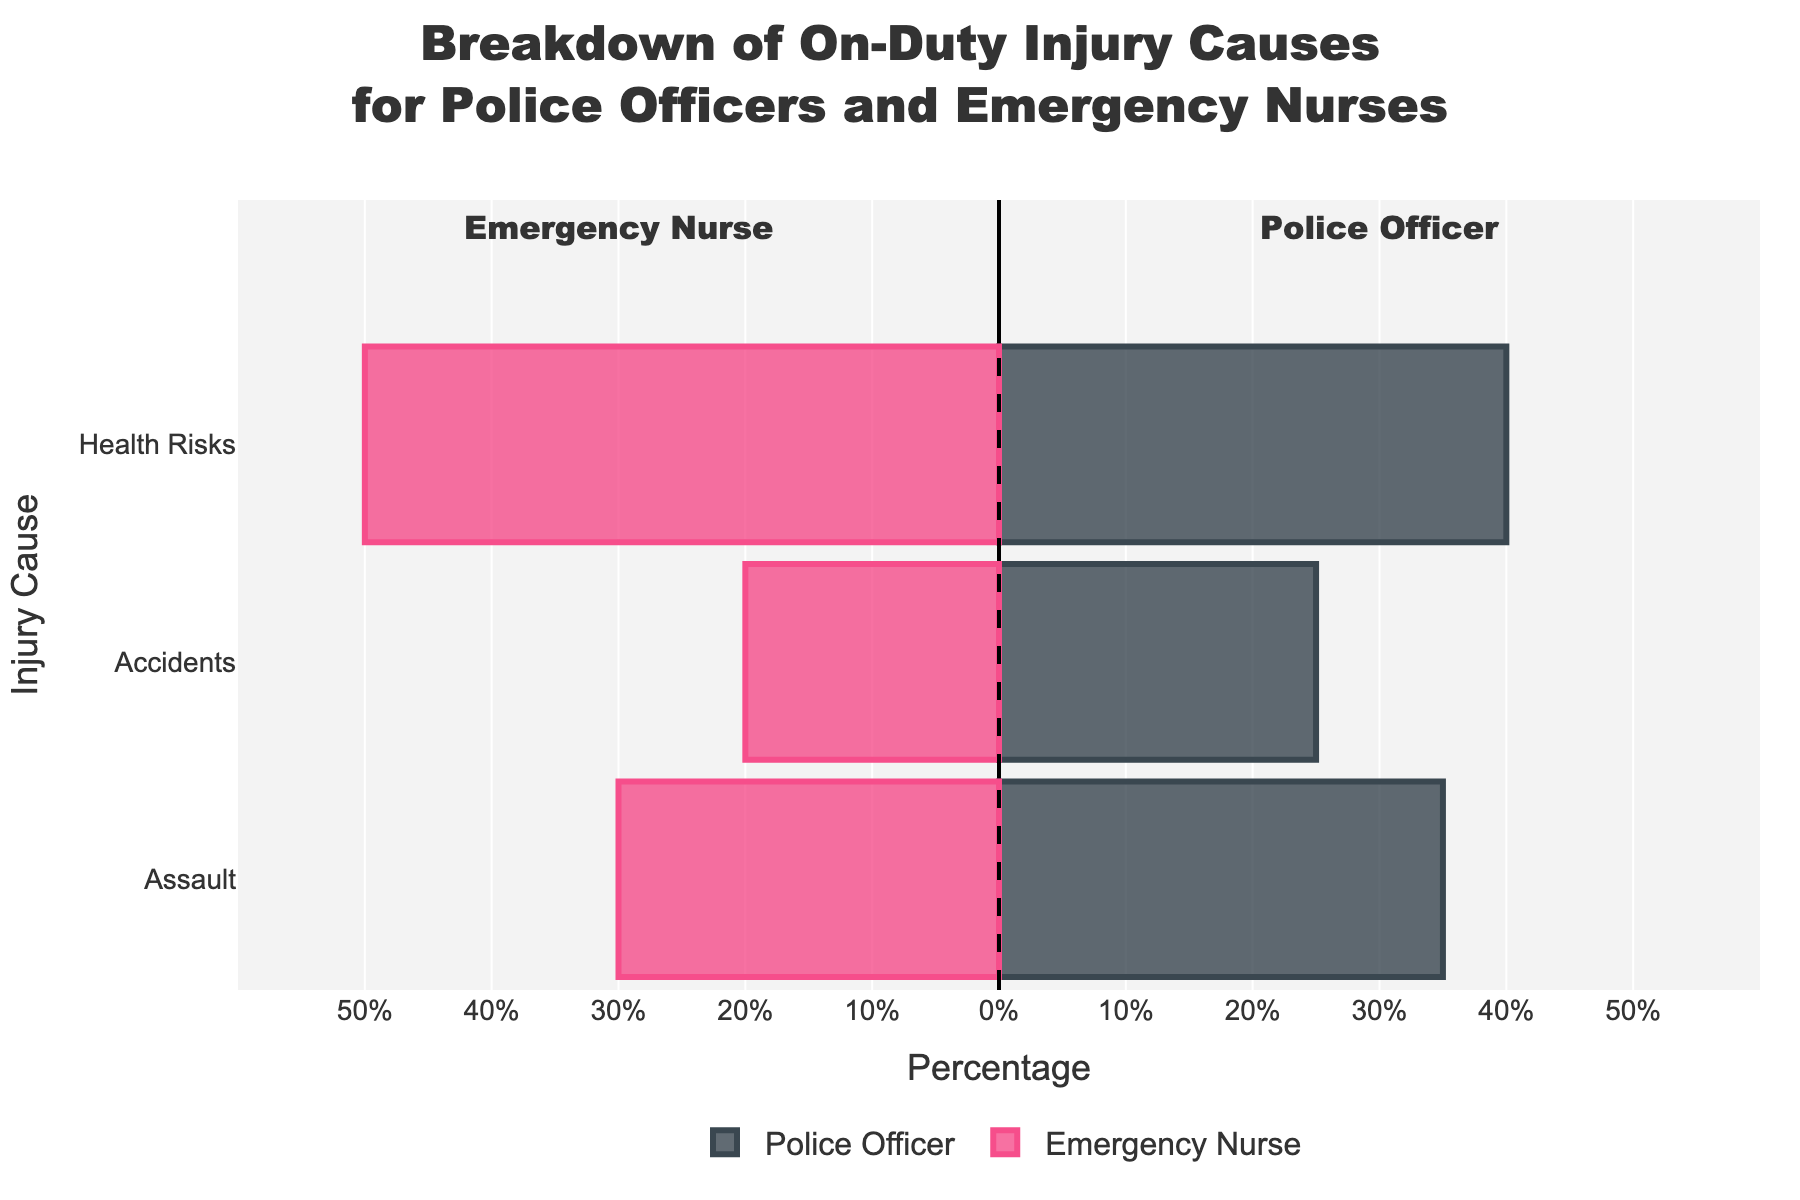What's the percentage of health risks for emergency nurses? The figure shows bars for each cause of injury. The bar representing health risks for emergency nurses extends to 50%.
Answer: 50% Which role has a higher percentage of injuries due to assaults? Compare the assault bars for both roles. The police officer's bar reaches 35%, while the emergency nurse's bar reaches 30%.
Answer: Police Officer What is the combined percentage of accidents for both roles? Add the percentages for both roles. The police officer has 25% and the emergency nurse has 20%. 25% + 20% = 45%
Answer: 45% Which injury cause has the lowest percentage for police officers? Compare the lengths of the police officer's bars. The accident bar is the shortest, representing 25%.
Answer: Accidents What is the difference in percentage of health risks between emergency nurses and police officers? Subtract the percentage of health risks for police officers (40%) from emergency nurses (50%). 50% - 40% = 10%
Answer: 10% Calculate the average percentage of assaults between police officers and emergency nurses. Add the assault percentages for both roles and divide by 2. (35% + 30%) / 2 = 32.5%
Answer: 32.5% Which role has a higher total combined percentage for all injury causes? Sum the percentages for each role. Police Officer: 35% + 25% + 40% = 100%. Emergency Nurse: 30% + 20% + 50% = 100%. Both roles are equal.
Answer: Both roles are equal What is the overall difference in percentage of accidents between police officers and emergency nurses? Subtract the percentage of accidents for emergency nurses (20%) from police officers (25%). 25% - 20% = 5%
Answer: 5% Which group has an equal distribution across all injury causes? Check if any role has bars of equal length for all causes. Neither role shows equal distribution across all causes as the percentages differ.
Answer: Neither 